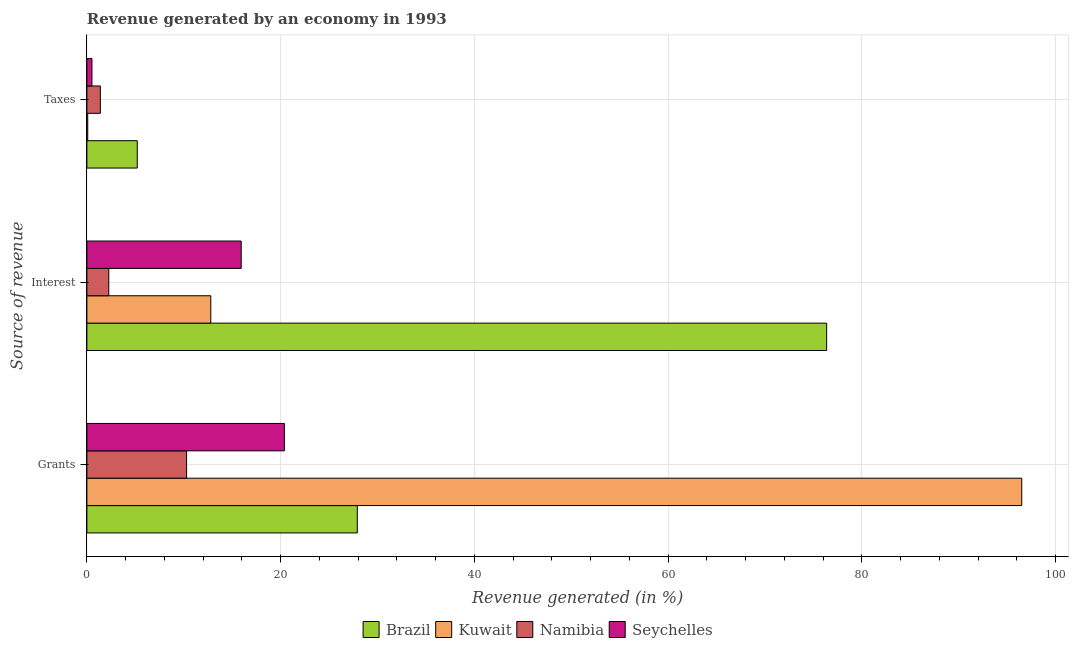How many different coloured bars are there?
Your answer should be very brief. 4. How many groups of bars are there?
Offer a terse response. 3. How many bars are there on the 3rd tick from the top?
Provide a short and direct response. 4. How many bars are there on the 3rd tick from the bottom?
Your response must be concise. 4. What is the label of the 3rd group of bars from the top?
Offer a terse response. Grants. What is the percentage of revenue generated by interest in Kuwait?
Give a very brief answer. 12.79. Across all countries, what is the maximum percentage of revenue generated by interest?
Provide a short and direct response. 76.37. Across all countries, what is the minimum percentage of revenue generated by interest?
Keep it short and to the point. 2.26. In which country was the percentage of revenue generated by interest maximum?
Provide a short and direct response. Brazil. In which country was the percentage of revenue generated by grants minimum?
Your response must be concise. Namibia. What is the total percentage of revenue generated by taxes in the graph?
Provide a succinct answer. 7.2. What is the difference between the percentage of revenue generated by grants in Kuwait and that in Seychelles?
Your answer should be compact. 76.12. What is the difference between the percentage of revenue generated by interest in Seychelles and the percentage of revenue generated by taxes in Kuwait?
Ensure brevity in your answer.  15.84. What is the average percentage of revenue generated by interest per country?
Provide a succinct answer. 26.84. What is the difference between the percentage of revenue generated by grants and percentage of revenue generated by taxes in Seychelles?
Your response must be concise. 19.87. In how many countries, is the percentage of revenue generated by taxes greater than 72 %?
Make the answer very short. 0. What is the ratio of the percentage of revenue generated by interest in Seychelles to that in Namibia?
Provide a short and direct response. 7.04. What is the difference between the highest and the second highest percentage of revenue generated by taxes?
Offer a very short reply. 3.81. What is the difference between the highest and the lowest percentage of revenue generated by grants?
Provide a succinct answer. 86.22. Is the sum of the percentage of revenue generated by grants in Seychelles and Kuwait greater than the maximum percentage of revenue generated by taxes across all countries?
Your answer should be compact. Yes. What does the 2nd bar from the top in Grants represents?
Your answer should be compact. Namibia. What does the 2nd bar from the bottom in Grants represents?
Your response must be concise. Kuwait. How many bars are there?
Keep it short and to the point. 12. How many countries are there in the graph?
Give a very brief answer. 4. Are the values on the major ticks of X-axis written in scientific E-notation?
Give a very brief answer. No. How many legend labels are there?
Your answer should be compact. 4. How are the legend labels stacked?
Keep it short and to the point. Horizontal. What is the title of the graph?
Offer a very short reply. Revenue generated by an economy in 1993. Does "Norway" appear as one of the legend labels in the graph?
Your answer should be very brief. No. What is the label or title of the X-axis?
Ensure brevity in your answer.  Revenue generated (in %). What is the label or title of the Y-axis?
Provide a succinct answer. Source of revenue. What is the Revenue generated (in %) of Brazil in Grants?
Offer a terse response. 27.92. What is the Revenue generated (in %) in Kuwait in Grants?
Provide a short and direct response. 96.52. What is the Revenue generated (in %) of Namibia in Grants?
Your response must be concise. 10.3. What is the Revenue generated (in %) in Seychelles in Grants?
Your answer should be compact. 20.39. What is the Revenue generated (in %) of Brazil in Interest?
Your answer should be very brief. 76.37. What is the Revenue generated (in %) of Kuwait in Interest?
Provide a short and direct response. 12.79. What is the Revenue generated (in %) in Namibia in Interest?
Your response must be concise. 2.26. What is the Revenue generated (in %) in Seychelles in Interest?
Offer a very short reply. 15.93. What is the Revenue generated (in %) in Brazil in Taxes?
Provide a succinct answer. 5.2. What is the Revenue generated (in %) of Kuwait in Taxes?
Your answer should be compact. 0.09. What is the Revenue generated (in %) of Namibia in Taxes?
Offer a terse response. 1.39. What is the Revenue generated (in %) of Seychelles in Taxes?
Your response must be concise. 0.52. Across all Source of revenue, what is the maximum Revenue generated (in %) in Brazil?
Offer a terse response. 76.37. Across all Source of revenue, what is the maximum Revenue generated (in %) of Kuwait?
Provide a short and direct response. 96.52. Across all Source of revenue, what is the maximum Revenue generated (in %) of Namibia?
Provide a succinct answer. 10.3. Across all Source of revenue, what is the maximum Revenue generated (in %) in Seychelles?
Offer a terse response. 20.39. Across all Source of revenue, what is the minimum Revenue generated (in %) of Brazil?
Your response must be concise. 5.2. Across all Source of revenue, what is the minimum Revenue generated (in %) of Kuwait?
Keep it short and to the point. 0.09. Across all Source of revenue, what is the minimum Revenue generated (in %) in Namibia?
Your response must be concise. 1.39. Across all Source of revenue, what is the minimum Revenue generated (in %) in Seychelles?
Keep it short and to the point. 0.52. What is the total Revenue generated (in %) of Brazil in the graph?
Your answer should be compact. 109.49. What is the total Revenue generated (in %) of Kuwait in the graph?
Keep it short and to the point. 109.4. What is the total Revenue generated (in %) in Namibia in the graph?
Provide a succinct answer. 13.95. What is the total Revenue generated (in %) of Seychelles in the graph?
Offer a very short reply. 36.85. What is the difference between the Revenue generated (in %) of Brazil in Grants and that in Interest?
Offer a terse response. -48.46. What is the difference between the Revenue generated (in %) of Kuwait in Grants and that in Interest?
Your answer should be very brief. 83.72. What is the difference between the Revenue generated (in %) of Namibia in Grants and that in Interest?
Ensure brevity in your answer.  8.03. What is the difference between the Revenue generated (in %) in Seychelles in Grants and that in Interest?
Give a very brief answer. 4.46. What is the difference between the Revenue generated (in %) in Brazil in Grants and that in Taxes?
Make the answer very short. 22.72. What is the difference between the Revenue generated (in %) of Kuwait in Grants and that in Taxes?
Offer a very short reply. 96.43. What is the difference between the Revenue generated (in %) of Namibia in Grants and that in Taxes?
Offer a terse response. 8.91. What is the difference between the Revenue generated (in %) in Seychelles in Grants and that in Taxes?
Make the answer very short. 19.87. What is the difference between the Revenue generated (in %) of Brazil in Interest and that in Taxes?
Keep it short and to the point. 71.17. What is the difference between the Revenue generated (in %) in Kuwait in Interest and that in Taxes?
Your answer should be very brief. 12.7. What is the difference between the Revenue generated (in %) of Namibia in Interest and that in Taxes?
Your answer should be compact. 0.87. What is the difference between the Revenue generated (in %) of Seychelles in Interest and that in Taxes?
Keep it short and to the point. 15.41. What is the difference between the Revenue generated (in %) of Brazil in Grants and the Revenue generated (in %) of Kuwait in Interest?
Provide a succinct answer. 15.13. What is the difference between the Revenue generated (in %) in Brazil in Grants and the Revenue generated (in %) in Namibia in Interest?
Provide a succinct answer. 25.66. What is the difference between the Revenue generated (in %) of Brazil in Grants and the Revenue generated (in %) of Seychelles in Interest?
Offer a terse response. 11.98. What is the difference between the Revenue generated (in %) in Kuwait in Grants and the Revenue generated (in %) in Namibia in Interest?
Your response must be concise. 94.25. What is the difference between the Revenue generated (in %) of Kuwait in Grants and the Revenue generated (in %) of Seychelles in Interest?
Offer a terse response. 80.58. What is the difference between the Revenue generated (in %) of Namibia in Grants and the Revenue generated (in %) of Seychelles in Interest?
Offer a very short reply. -5.64. What is the difference between the Revenue generated (in %) of Brazil in Grants and the Revenue generated (in %) of Kuwait in Taxes?
Offer a very short reply. 27.83. What is the difference between the Revenue generated (in %) in Brazil in Grants and the Revenue generated (in %) in Namibia in Taxes?
Give a very brief answer. 26.53. What is the difference between the Revenue generated (in %) in Brazil in Grants and the Revenue generated (in %) in Seychelles in Taxes?
Offer a terse response. 27.39. What is the difference between the Revenue generated (in %) in Kuwait in Grants and the Revenue generated (in %) in Namibia in Taxes?
Provide a short and direct response. 95.13. What is the difference between the Revenue generated (in %) of Kuwait in Grants and the Revenue generated (in %) of Seychelles in Taxes?
Your answer should be compact. 95.99. What is the difference between the Revenue generated (in %) in Namibia in Grants and the Revenue generated (in %) in Seychelles in Taxes?
Your response must be concise. 9.77. What is the difference between the Revenue generated (in %) of Brazil in Interest and the Revenue generated (in %) of Kuwait in Taxes?
Give a very brief answer. 76.29. What is the difference between the Revenue generated (in %) in Brazil in Interest and the Revenue generated (in %) in Namibia in Taxes?
Give a very brief answer. 74.98. What is the difference between the Revenue generated (in %) in Brazil in Interest and the Revenue generated (in %) in Seychelles in Taxes?
Provide a succinct answer. 75.85. What is the difference between the Revenue generated (in %) of Kuwait in Interest and the Revenue generated (in %) of Namibia in Taxes?
Provide a short and direct response. 11.4. What is the difference between the Revenue generated (in %) of Kuwait in Interest and the Revenue generated (in %) of Seychelles in Taxes?
Your answer should be compact. 12.27. What is the difference between the Revenue generated (in %) in Namibia in Interest and the Revenue generated (in %) in Seychelles in Taxes?
Your answer should be compact. 1.74. What is the average Revenue generated (in %) in Brazil per Source of revenue?
Your answer should be very brief. 36.5. What is the average Revenue generated (in %) in Kuwait per Source of revenue?
Offer a terse response. 36.47. What is the average Revenue generated (in %) in Namibia per Source of revenue?
Provide a short and direct response. 4.65. What is the average Revenue generated (in %) of Seychelles per Source of revenue?
Offer a very short reply. 12.28. What is the difference between the Revenue generated (in %) in Brazil and Revenue generated (in %) in Kuwait in Grants?
Make the answer very short. -68.6. What is the difference between the Revenue generated (in %) of Brazil and Revenue generated (in %) of Namibia in Grants?
Offer a very short reply. 17.62. What is the difference between the Revenue generated (in %) in Brazil and Revenue generated (in %) in Seychelles in Grants?
Keep it short and to the point. 7.53. What is the difference between the Revenue generated (in %) in Kuwait and Revenue generated (in %) in Namibia in Grants?
Give a very brief answer. 86.22. What is the difference between the Revenue generated (in %) in Kuwait and Revenue generated (in %) in Seychelles in Grants?
Give a very brief answer. 76.12. What is the difference between the Revenue generated (in %) in Namibia and Revenue generated (in %) in Seychelles in Grants?
Your answer should be very brief. -10.1. What is the difference between the Revenue generated (in %) of Brazil and Revenue generated (in %) of Kuwait in Interest?
Offer a terse response. 63.58. What is the difference between the Revenue generated (in %) in Brazil and Revenue generated (in %) in Namibia in Interest?
Your response must be concise. 74.11. What is the difference between the Revenue generated (in %) in Brazil and Revenue generated (in %) in Seychelles in Interest?
Give a very brief answer. 60.44. What is the difference between the Revenue generated (in %) of Kuwait and Revenue generated (in %) of Namibia in Interest?
Keep it short and to the point. 10.53. What is the difference between the Revenue generated (in %) in Kuwait and Revenue generated (in %) in Seychelles in Interest?
Your answer should be very brief. -3.14. What is the difference between the Revenue generated (in %) in Namibia and Revenue generated (in %) in Seychelles in Interest?
Ensure brevity in your answer.  -13.67. What is the difference between the Revenue generated (in %) in Brazil and Revenue generated (in %) in Kuwait in Taxes?
Offer a terse response. 5.11. What is the difference between the Revenue generated (in %) in Brazil and Revenue generated (in %) in Namibia in Taxes?
Make the answer very short. 3.81. What is the difference between the Revenue generated (in %) of Brazil and Revenue generated (in %) of Seychelles in Taxes?
Your response must be concise. 4.68. What is the difference between the Revenue generated (in %) of Kuwait and Revenue generated (in %) of Namibia in Taxes?
Provide a short and direct response. -1.3. What is the difference between the Revenue generated (in %) in Kuwait and Revenue generated (in %) in Seychelles in Taxes?
Your answer should be very brief. -0.44. What is the difference between the Revenue generated (in %) in Namibia and Revenue generated (in %) in Seychelles in Taxes?
Your answer should be compact. 0.87. What is the ratio of the Revenue generated (in %) in Brazil in Grants to that in Interest?
Provide a succinct answer. 0.37. What is the ratio of the Revenue generated (in %) of Kuwait in Grants to that in Interest?
Provide a succinct answer. 7.54. What is the ratio of the Revenue generated (in %) in Namibia in Grants to that in Interest?
Offer a very short reply. 4.55. What is the ratio of the Revenue generated (in %) in Seychelles in Grants to that in Interest?
Offer a very short reply. 1.28. What is the ratio of the Revenue generated (in %) in Brazil in Grants to that in Taxes?
Give a very brief answer. 5.37. What is the ratio of the Revenue generated (in %) in Kuwait in Grants to that in Taxes?
Offer a terse response. 1094. What is the ratio of the Revenue generated (in %) in Namibia in Grants to that in Taxes?
Offer a very short reply. 7.41. What is the ratio of the Revenue generated (in %) in Seychelles in Grants to that in Taxes?
Keep it short and to the point. 38.91. What is the ratio of the Revenue generated (in %) of Brazil in Interest to that in Taxes?
Your response must be concise. 14.68. What is the ratio of the Revenue generated (in %) of Kuwait in Interest to that in Taxes?
Offer a very short reply. 145. What is the ratio of the Revenue generated (in %) of Namibia in Interest to that in Taxes?
Ensure brevity in your answer.  1.63. What is the ratio of the Revenue generated (in %) in Seychelles in Interest to that in Taxes?
Ensure brevity in your answer.  30.41. What is the difference between the highest and the second highest Revenue generated (in %) in Brazil?
Keep it short and to the point. 48.46. What is the difference between the highest and the second highest Revenue generated (in %) of Kuwait?
Ensure brevity in your answer.  83.72. What is the difference between the highest and the second highest Revenue generated (in %) of Namibia?
Ensure brevity in your answer.  8.03. What is the difference between the highest and the second highest Revenue generated (in %) of Seychelles?
Offer a very short reply. 4.46. What is the difference between the highest and the lowest Revenue generated (in %) in Brazil?
Your answer should be very brief. 71.17. What is the difference between the highest and the lowest Revenue generated (in %) of Kuwait?
Offer a very short reply. 96.43. What is the difference between the highest and the lowest Revenue generated (in %) in Namibia?
Give a very brief answer. 8.91. What is the difference between the highest and the lowest Revenue generated (in %) of Seychelles?
Your response must be concise. 19.87. 